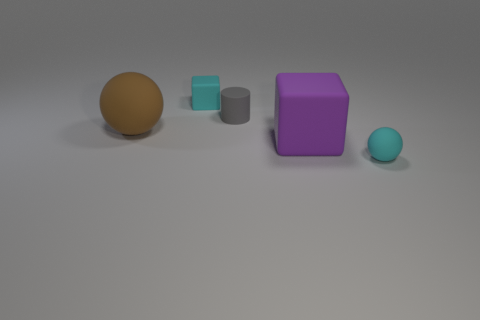Add 5 small cyan things. How many objects exist? 10 Subtract all cyan spheres. How many spheres are left? 1 Subtract all blocks. How many objects are left? 3 Subtract all brown spheres. Subtract all cyan cubes. How many spheres are left? 1 Subtract all large purple things. Subtract all large purple matte objects. How many objects are left? 3 Add 3 gray rubber cylinders. How many gray rubber cylinders are left? 4 Add 3 small cyan matte things. How many small cyan matte things exist? 5 Subtract 0 blue balls. How many objects are left? 5 